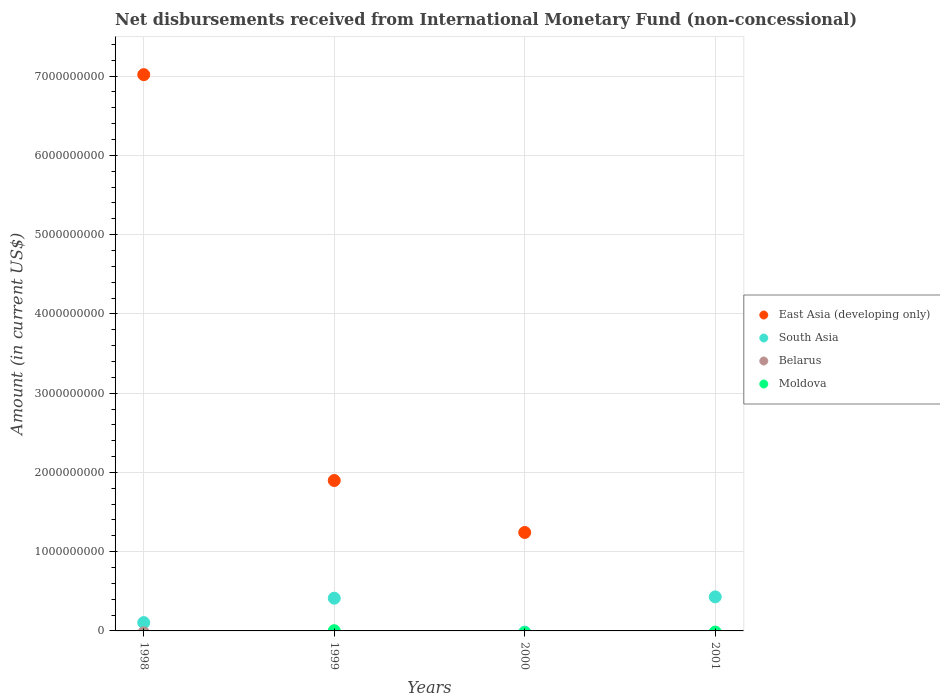What is the amount of disbursements received from International Monetary Fund in Moldova in 1999?
Provide a short and direct response. 2.92e+06. Across all years, what is the maximum amount of disbursements received from International Monetary Fund in South Asia?
Your answer should be very brief. 4.30e+08. Across all years, what is the minimum amount of disbursements received from International Monetary Fund in Belarus?
Your response must be concise. 0. In which year was the amount of disbursements received from International Monetary Fund in South Asia maximum?
Your answer should be compact. 2001. What is the total amount of disbursements received from International Monetary Fund in South Asia in the graph?
Your response must be concise. 9.48e+08. What is the difference between the amount of disbursements received from International Monetary Fund in East Asia (developing only) in 1998 and that in 2000?
Offer a terse response. 5.78e+09. What is the difference between the amount of disbursements received from International Monetary Fund in South Asia in 1998 and the amount of disbursements received from International Monetary Fund in East Asia (developing only) in 1999?
Provide a short and direct response. -1.79e+09. What is the average amount of disbursements received from International Monetary Fund in South Asia per year?
Your answer should be very brief. 2.37e+08. In how many years, is the amount of disbursements received from International Monetary Fund in East Asia (developing only) greater than 5000000000 US$?
Offer a terse response. 1. What is the ratio of the amount of disbursements received from International Monetary Fund in East Asia (developing only) in 1999 to that in 2000?
Your answer should be very brief. 1.53. Is the amount of disbursements received from International Monetary Fund in East Asia (developing only) in 1999 less than that in 2000?
Ensure brevity in your answer.  No. What is the difference between the highest and the second highest amount of disbursements received from International Monetary Fund in South Asia?
Keep it short and to the point. 1.68e+07. What is the difference between the highest and the lowest amount of disbursements received from International Monetary Fund in East Asia (developing only)?
Give a very brief answer. 7.02e+09. Is it the case that in every year, the sum of the amount of disbursements received from International Monetary Fund in South Asia and amount of disbursements received from International Monetary Fund in Moldova  is greater than the sum of amount of disbursements received from International Monetary Fund in Belarus and amount of disbursements received from International Monetary Fund in East Asia (developing only)?
Keep it short and to the point. No. Does the amount of disbursements received from International Monetary Fund in Moldova monotonically increase over the years?
Ensure brevity in your answer.  No. How many years are there in the graph?
Make the answer very short. 4. Are the values on the major ticks of Y-axis written in scientific E-notation?
Offer a terse response. No. Does the graph contain any zero values?
Your response must be concise. Yes. Where does the legend appear in the graph?
Make the answer very short. Center right. How are the legend labels stacked?
Ensure brevity in your answer.  Vertical. What is the title of the graph?
Ensure brevity in your answer.  Net disbursements received from International Monetary Fund (non-concessional). What is the label or title of the Y-axis?
Provide a short and direct response. Amount (in current US$). What is the Amount (in current US$) in East Asia (developing only) in 1998?
Keep it short and to the point. 7.02e+09. What is the Amount (in current US$) in South Asia in 1998?
Offer a very short reply. 1.05e+08. What is the Amount (in current US$) in Belarus in 1998?
Your response must be concise. 0. What is the Amount (in current US$) in East Asia (developing only) in 1999?
Give a very brief answer. 1.90e+09. What is the Amount (in current US$) of South Asia in 1999?
Provide a short and direct response. 4.13e+08. What is the Amount (in current US$) in Moldova in 1999?
Give a very brief answer. 2.92e+06. What is the Amount (in current US$) in East Asia (developing only) in 2000?
Give a very brief answer. 1.24e+09. What is the Amount (in current US$) of Belarus in 2000?
Give a very brief answer. 0. What is the Amount (in current US$) of Moldova in 2000?
Ensure brevity in your answer.  0. What is the Amount (in current US$) in East Asia (developing only) in 2001?
Offer a very short reply. 0. What is the Amount (in current US$) of South Asia in 2001?
Provide a succinct answer. 4.30e+08. What is the Amount (in current US$) of Belarus in 2001?
Offer a terse response. 0. Across all years, what is the maximum Amount (in current US$) in East Asia (developing only)?
Your response must be concise. 7.02e+09. Across all years, what is the maximum Amount (in current US$) in South Asia?
Keep it short and to the point. 4.30e+08. Across all years, what is the maximum Amount (in current US$) of Moldova?
Offer a terse response. 2.92e+06. Across all years, what is the minimum Amount (in current US$) of Moldova?
Provide a short and direct response. 0. What is the total Amount (in current US$) of East Asia (developing only) in the graph?
Provide a short and direct response. 1.02e+1. What is the total Amount (in current US$) of South Asia in the graph?
Give a very brief answer. 9.48e+08. What is the total Amount (in current US$) in Moldova in the graph?
Your response must be concise. 2.92e+06. What is the difference between the Amount (in current US$) of East Asia (developing only) in 1998 and that in 1999?
Make the answer very short. 5.12e+09. What is the difference between the Amount (in current US$) of South Asia in 1998 and that in 1999?
Give a very brief answer. -3.08e+08. What is the difference between the Amount (in current US$) in East Asia (developing only) in 1998 and that in 2000?
Offer a terse response. 5.78e+09. What is the difference between the Amount (in current US$) in South Asia in 1998 and that in 2001?
Keep it short and to the point. -3.25e+08. What is the difference between the Amount (in current US$) in East Asia (developing only) in 1999 and that in 2000?
Provide a short and direct response. 6.56e+08. What is the difference between the Amount (in current US$) of South Asia in 1999 and that in 2001?
Keep it short and to the point. -1.68e+07. What is the difference between the Amount (in current US$) of East Asia (developing only) in 1998 and the Amount (in current US$) of South Asia in 1999?
Give a very brief answer. 6.61e+09. What is the difference between the Amount (in current US$) of East Asia (developing only) in 1998 and the Amount (in current US$) of Moldova in 1999?
Provide a succinct answer. 7.02e+09. What is the difference between the Amount (in current US$) of South Asia in 1998 and the Amount (in current US$) of Moldova in 1999?
Offer a terse response. 1.02e+08. What is the difference between the Amount (in current US$) of East Asia (developing only) in 1998 and the Amount (in current US$) of South Asia in 2001?
Your response must be concise. 6.59e+09. What is the difference between the Amount (in current US$) of East Asia (developing only) in 1999 and the Amount (in current US$) of South Asia in 2001?
Provide a short and direct response. 1.47e+09. What is the difference between the Amount (in current US$) in East Asia (developing only) in 2000 and the Amount (in current US$) in South Asia in 2001?
Your response must be concise. 8.12e+08. What is the average Amount (in current US$) in East Asia (developing only) per year?
Provide a short and direct response. 2.54e+09. What is the average Amount (in current US$) in South Asia per year?
Make the answer very short. 2.37e+08. What is the average Amount (in current US$) of Moldova per year?
Your response must be concise. 7.30e+05. In the year 1998, what is the difference between the Amount (in current US$) of East Asia (developing only) and Amount (in current US$) of South Asia?
Provide a short and direct response. 6.91e+09. In the year 1999, what is the difference between the Amount (in current US$) in East Asia (developing only) and Amount (in current US$) in South Asia?
Your answer should be compact. 1.48e+09. In the year 1999, what is the difference between the Amount (in current US$) in East Asia (developing only) and Amount (in current US$) in Moldova?
Keep it short and to the point. 1.89e+09. In the year 1999, what is the difference between the Amount (in current US$) in South Asia and Amount (in current US$) in Moldova?
Your response must be concise. 4.10e+08. What is the ratio of the Amount (in current US$) of East Asia (developing only) in 1998 to that in 1999?
Provide a short and direct response. 3.7. What is the ratio of the Amount (in current US$) of South Asia in 1998 to that in 1999?
Provide a short and direct response. 0.25. What is the ratio of the Amount (in current US$) of East Asia (developing only) in 1998 to that in 2000?
Your answer should be compact. 5.65. What is the ratio of the Amount (in current US$) of South Asia in 1998 to that in 2001?
Make the answer very short. 0.24. What is the ratio of the Amount (in current US$) of East Asia (developing only) in 1999 to that in 2000?
Your response must be concise. 1.53. What is the ratio of the Amount (in current US$) of South Asia in 1999 to that in 2001?
Your answer should be very brief. 0.96. What is the difference between the highest and the second highest Amount (in current US$) of East Asia (developing only)?
Give a very brief answer. 5.12e+09. What is the difference between the highest and the second highest Amount (in current US$) in South Asia?
Give a very brief answer. 1.68e+07. What is the difference between the highest and the lowest Amount (in current US$) in East Asia (developing only)?
Your answer should be compact. 7.02e+09. What is the difference between the highest and the lowest Amount (in current US$) of South Asia?
Make the answer very short. 4.30e+08. What is the difference between the highest and the lowest Amount (in current US$) of Moldova?
Ensure brevity in your answer.  2.92e+06. 